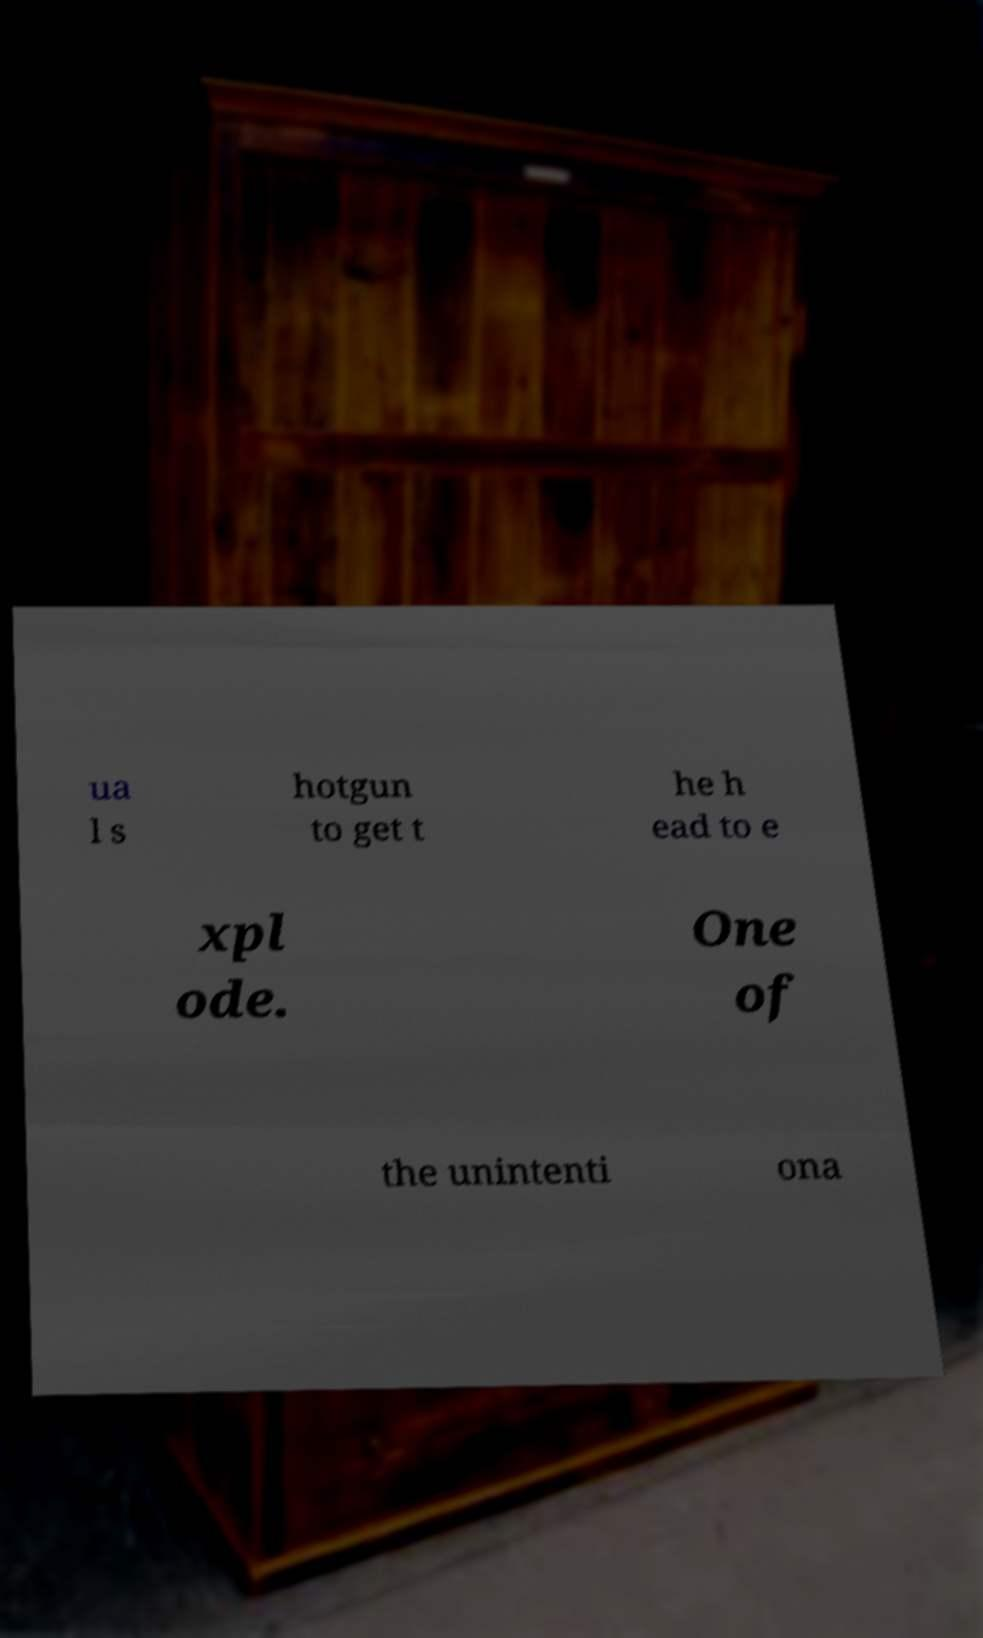What messages or text are displayed in this image? I need them in a readable, typed format. ua l s hotgun to get t he h ead to e xpl ode. One of the unintenti ona 